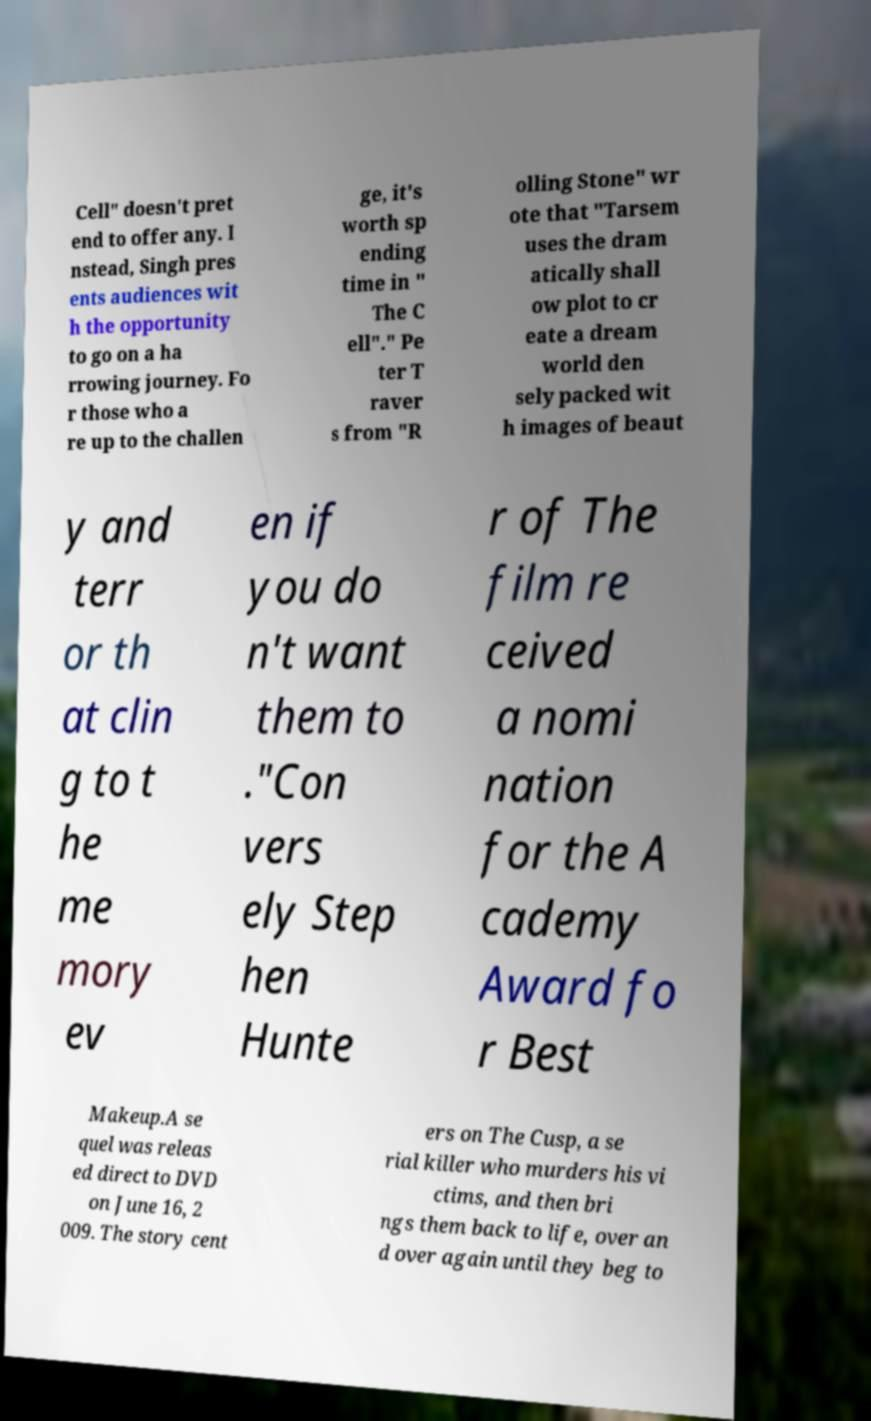Can you accurately transcribe the text from the provided image for me? Cell" doesn't pret end to offer any. I nstead, Singh pres ents audiences wit h the opportunity to go on a ha rrowing journey. Fo r those who a re up to the challen ge, it's worth sp ending time in " The C ell"." Pe ter T raver s from "R olling Stone" wr ote that "Tarsem uses the dram atically shall ow plot to cr eate a dream world den sely packed wit h images of beaut y and terr or th at clin g to t he me mory ev en if you do n't want them to ."Con vers ely Step hen Hunte r of The film re ceived a nomi nation for the A cademy Award fo r Best Makeup.A se quel was releas ed direct to DVD on June 16, 2 009. The story cent ers on The Cusp, a se rial killer who murders his vi ctims, and then bri ngs them back to life, over an d over again until they beg to 